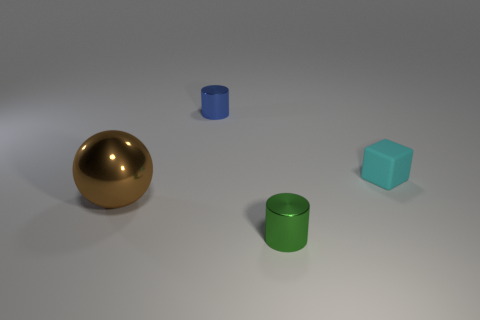Can you speculate on the materials these objects might be made of? The golden sphere and the shiny cylinders suggest a metallic material, considering their reflective surfaces. The sphere could be a polished brass or gold-plated object. The cylinders might be anodized aluminum given their color and sheen. The cube's lack of reflections and diffused light interactions hints at a matte, possibly plastic material. 